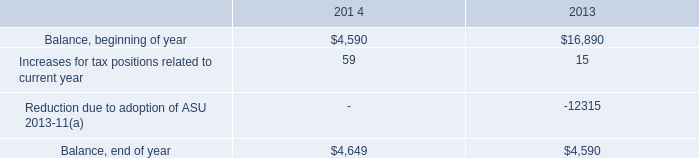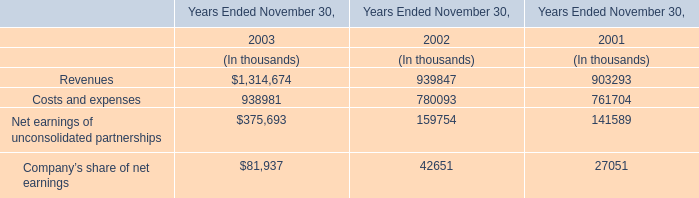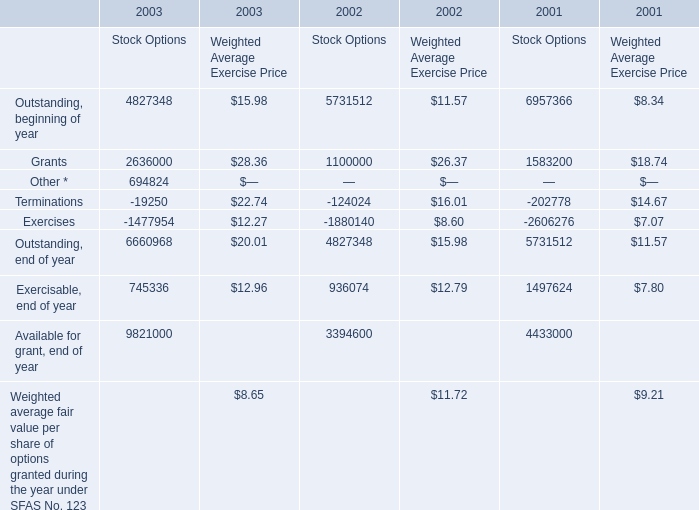what was the percentage decrease in the 2013 balance from the beginning of the year to the end of the year? 
Computations: ((16890 - 4590) / 16890)
Answer: 0.72824. 